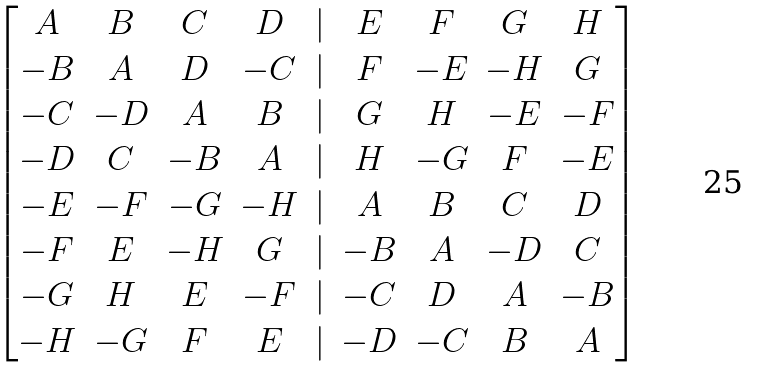Convert formula to latex. <formula><loc_0><loc_0><loc_500><loc_500>\begin{bmatrix} A & B & C & D & | & E & F & G & H \\ - B & A & D & - C & | & F & - E & - H & G \\ - C & - D & A & B & | & G & H & - E & - F \\ - D & C & - B & A & | & H & - G & F & - E \\ - E & - F & - G & - H & | & A & B & C & D \\ - F & E & - H & G & | & - B & A & - D & C \\ - G & H & E & - F & | & - C & D & A & - B \\ - H & - G & F & E & | & - D & - C & B & A \\ \end{bmatrix}</formula> 